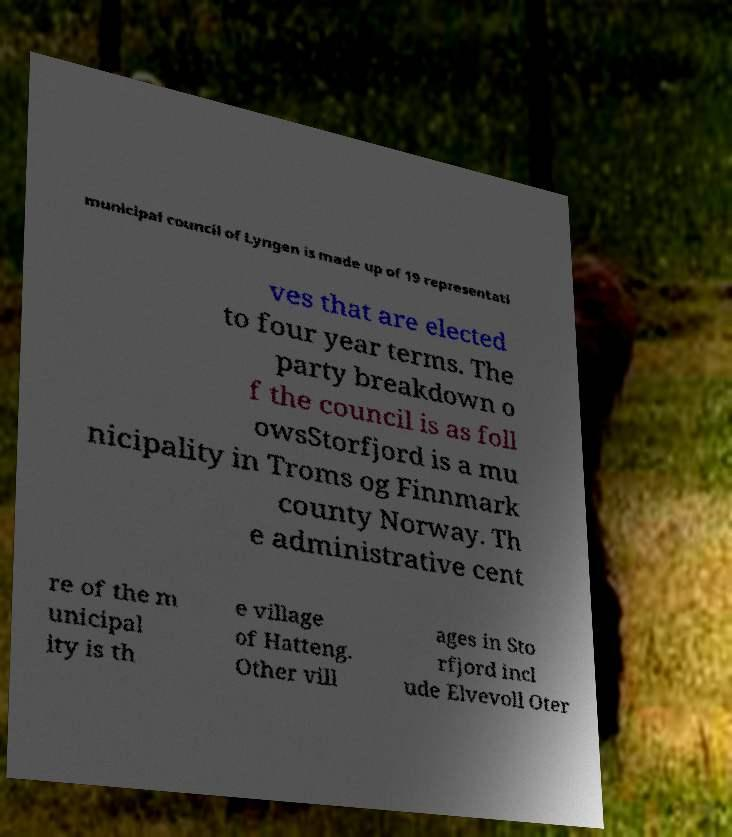Please identify and transcribe the text found in this image. municipal council of Lyngen is made up of 19 representati ves that are elected to four year terms. The party breakdown o f the council is as foll owsStorfjord is a mu nicipality in Troms og Finnmark county Norway. Th e administrative cent re of the m unicipal ity is th e village of Hatteng. Other vill ages in Sto rfjord incl ude Elvevoll Oter 